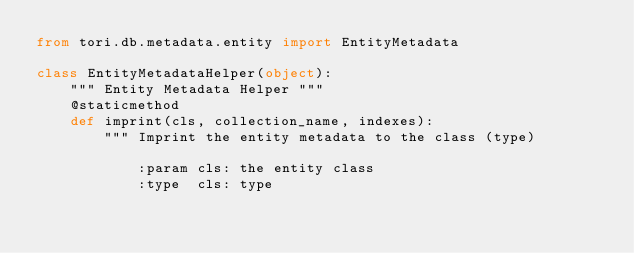<code> <loc_0><loc_0><loc_500><loc_500><_Python_>from tori.db.metadata.entity import EntityMetadata

class EntityMetadataHelper(object):
    """ Entity Metadata Helper """
    @staticmethod
    def imprint(cls, collection_name, indexes):
        """ Imprint the entity metadata to the class (type)

            :param cls: the entity class
            :type  cls: type</code> 